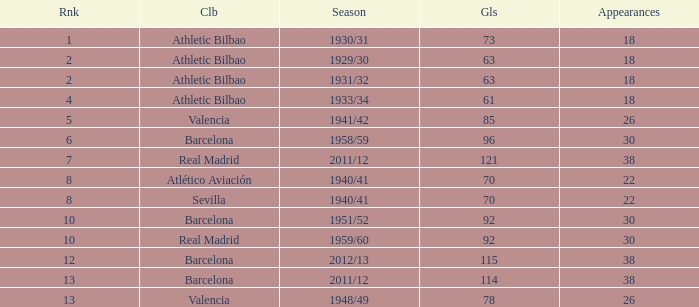What are the apps for less than 61 goals and before rank 6? None. 